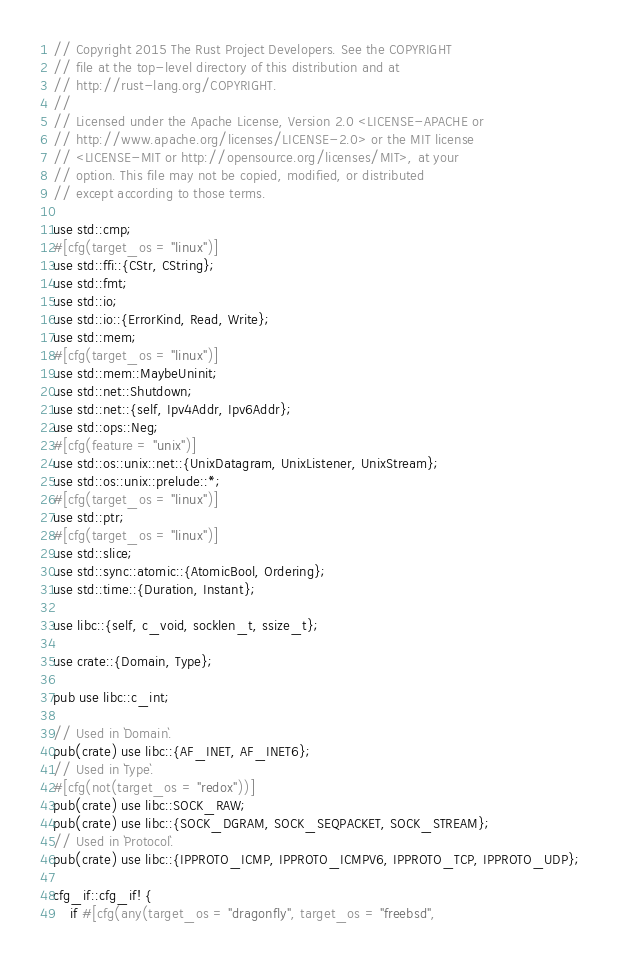Convert code to text. <code><loc_0><loc_0><loc_500><loc_500><_Rust_>// Copyright 2015 The Rust Project Developers. See the COPYRIGHT
// file at the top-level directory of this distribution and at
// http://rust-lang.org/COPYRIGHT.
//
// Licensed under the Apache License, Version 2.0 <LICENSE-APACHE or
// http://www.apache.org/licenses/LICENSE-2.0> or the MIT license
// <LICENSE-MIT or http://opensource.org/licenses/MIT>, at your
// option. This file may not be copied, modified, or distributed
// except according to those terms.

use std::cmp;
#[cfg(target_os = "linux")]
use std::ffi::{CStr, CString};
use std::fmt;
use std::io;
use std::io::{ErrorKind, Read, Write};
use std::mem;
#[cfg(target_os = "linux")]
use std::mem::MaybeUninit;
use std::net::Shutdown;
use std::net::{self, Ipv4Addr, Ipv6Addr};
use std::ops::Neg;
#[cfg(feature = "unix")]
use std::os::unix::net::{UnixDatagram, UnixListener, UnixStream};
use std::os::unix::prelude::*;
#[cfg(target_os = "linux")]
use std::ptr;
#[cfg(target_os = "linux")]
use std::slice;
use std::sync::atomic::{AtomicBool, Ordering};
use std::time::{Duration, Instant};

use libc::{self, c_void, socklen_t, ssize_t};

use crate::{Domain, Type};

pub use libc::c_int;

// Used in `Domain`.
pub(crate) use libc::{AF_INET, AF_INET6};
// Used in `Type`.
#[cfg(not(target_os = "redox"))]
pub(crate) use libc::SOCK_RAW;
pub(crate) use libc::{SOCK_DGRAM, SOCK_SEQPACKET, SOCK_STREAM};
// Used in `Protocol`.
pub(crate) use libc::{IPPROTO_ICMP, IPPROTO_ICMPV6, IPPROTO_TCP, IPPROTO_UDP};

cfg_if::cfg_if! {
    if #[cfg(any(target_os = "dragonfly", target_os = "freebsd",</code> 